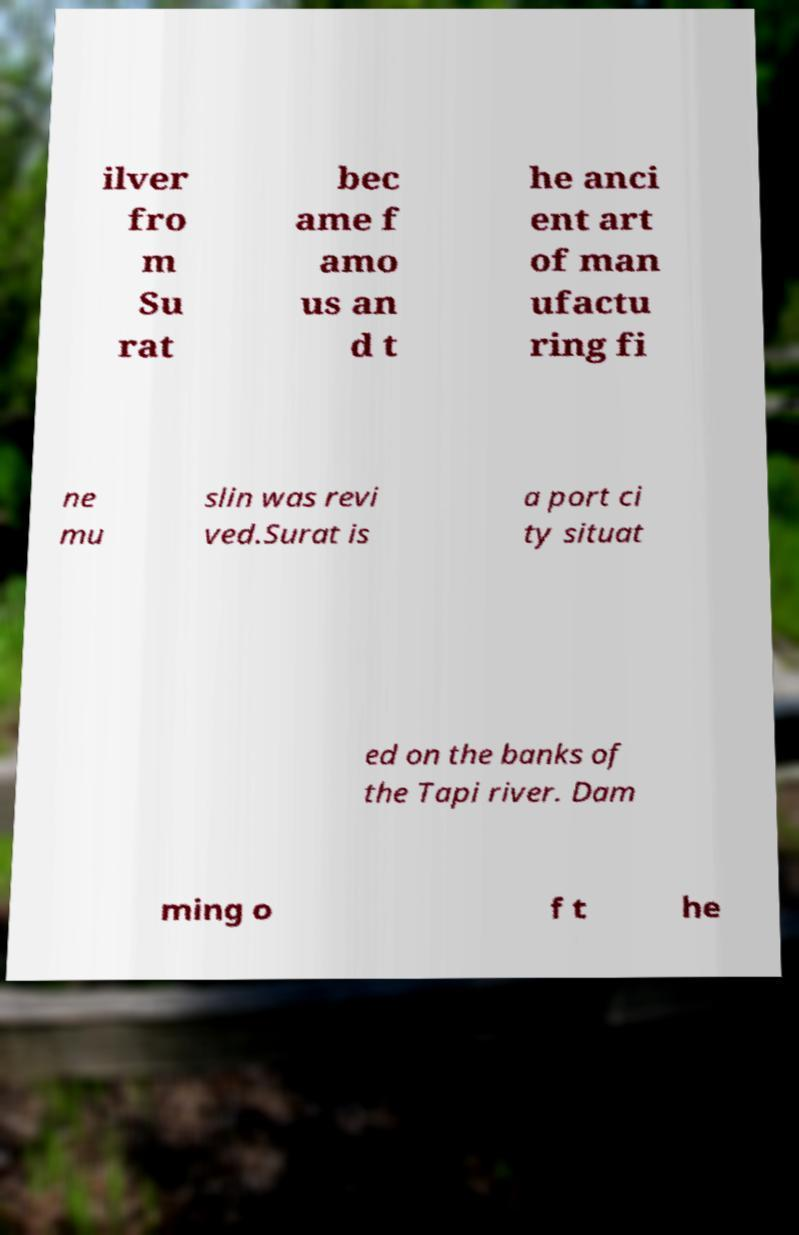Could you assist in decoding the text presented in this image and type it out clearly? ilver fro m Su rat bec ame f amo us an d t he anci ent art of man ufactu ring fi ne mu slin was revi ved.Surat is a port ci ty situat ed on the banks of the Tapi river. Dam ming o f t he 